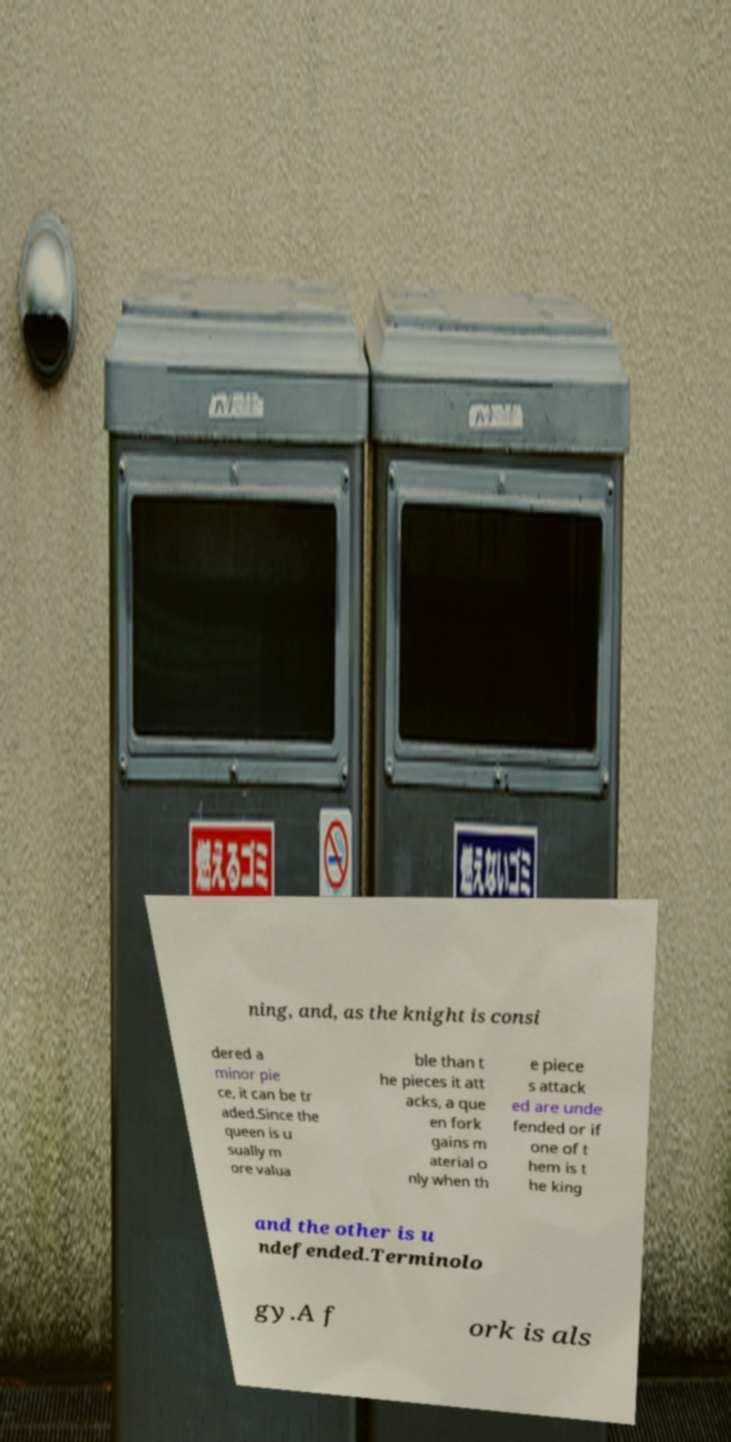Please read and relay the text visible in this image. What does it say? ning, and, as the knight is consi dered a minor pie ce, it can be tr aded.Since the queen is u sually m ore valua ble than t he pieces it att acks, a que en fork gains m aterial o nly when th e piece s attack ed are unde fended or if one of t hem is t he king and the other is u ndefended.Terminolo gy.A f ork is als 